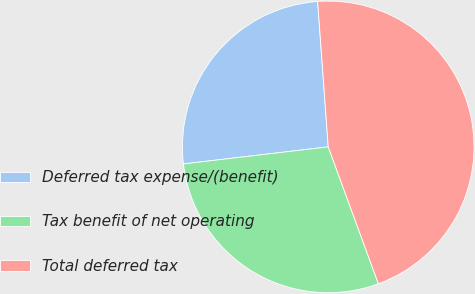Convert chart to OTSL. <chart><loc_0><loc_0><loc_500><loc_500><pie_chart><fcel>Deferred tax expense/(benefit)<fcel>Tax benefit of net operating<fcel>Total deferred tax<nl><fcel>25.71%<fcel>28.72%<fcel>45.57%<nl></chart> 